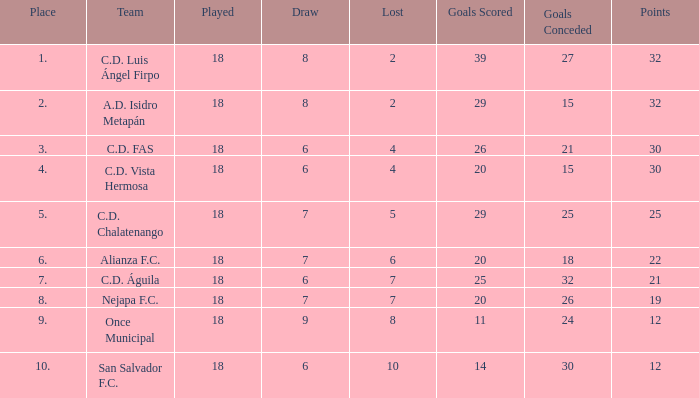Parse the table in full. {'header': ['Place', 'Team', 'Played', 'Draw', 'Lost', 'Goals Scored', 'Goals Conceded', 'Points'], 'rows': [['1.', 'C.D. Luis Ángel Firpo', '18', '8', '2', '39', '27', '32'], ['2.', 'A.D. Isidro Metapán', '18', '8', '2', '29', '15', '32'], ['3.', 'C.D. FAS', '18', '6', '4', '26', '21', '30'], ['4.', 'C.D. Vista Hermosa', '18', '6', '4', '20', '15', '30'], ['5.', 'C.D. Chalatenango', '18', '7', '5', '29', '25', '25'], ['6.', 'Alianza F.C.', '18', '7', '6', '20', '18', '22'], ['7.', 'C.D. Águila', '18', '6', '7', '25', '32', '21'], ['8.', 'Nejapa F.C.', '18', '7', '7', '20', '26', '19'], ['9.', 'Once Municipal', '18', '9', '8', '11', '24', '12'], ['10.', 'San Salvador F.C.', '18', '6', '10', '14', '30', '12']]} What is the sum of all points less than 12 in a given location? 0.0. 